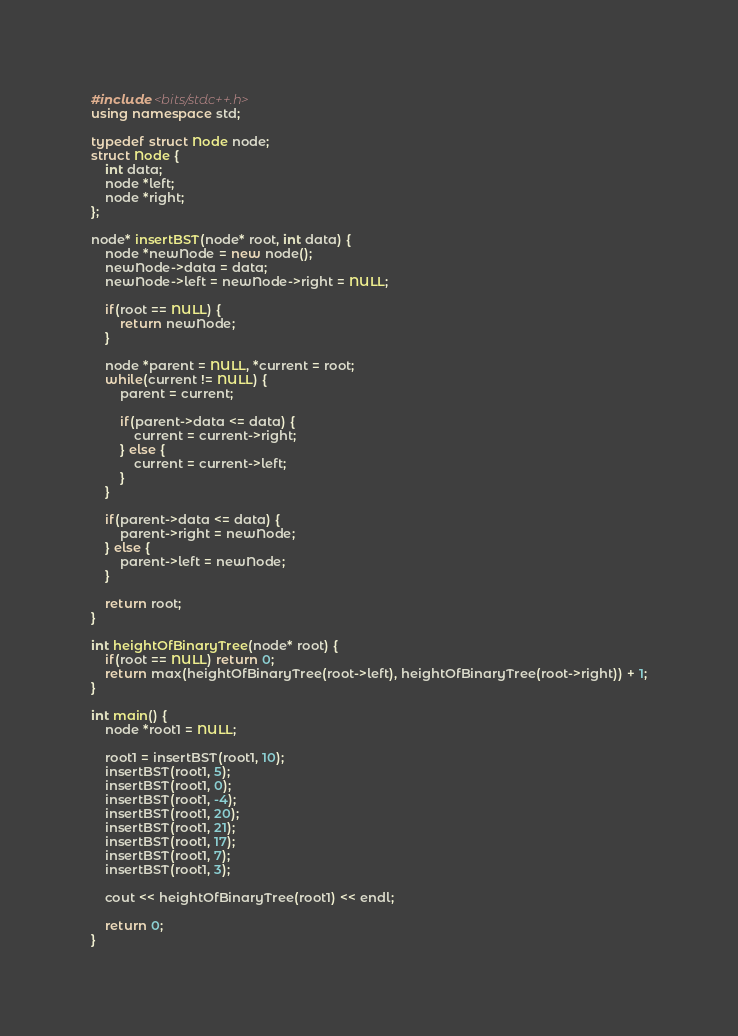Convert code to text. <code><loc_0><loc_0><loc_500><loc_500><_C++_>#include <bits/stdc++.h>
using namespace std;

typedef struct Node node;
struct Node {
    int data;
    node *left;
    node *right;
};

node* insertBST(node* root, int data) {
    node *newNode = new node();
    newNode->data = data;
    newNode->left = newNode->right = NULL;

    if(root == NULL) {
        return newNode;
    }

    node *parent = NULL, *current = root;
    while(current != NULL) {
        parent = current;

        if(parent->data <= data) {
            current = current->right;
        } else {
            current = current->left;
        }
    }

    if(parent->data <= data) {
        parent->right = newNode;
    } else {
        parent->left = newNode;
    }

    return root;
}

int heightOfBinaryTree(node* root) {
    if(root == NULL) return 0;
    return max(heightOfBinaryTree(root->left), heightOfBinaryTree(root->right)) + 1;
}

int main() {
    node *root1 = NULL;

    root1 = insertBST(root1, 10);
    insertBST(root1, 5);
    insertBST(root1, 0);
    insertBST(root1, -4);
    insertBST(root1, 20);
    insertBST(root1, 21);
    insertBST(root1, 17);
    insertBST(root1, 7);
    insertBST(root1, 3);

    cout << heightOfBinaryTree(root1) << endl;

    return 0;
}



</code> 